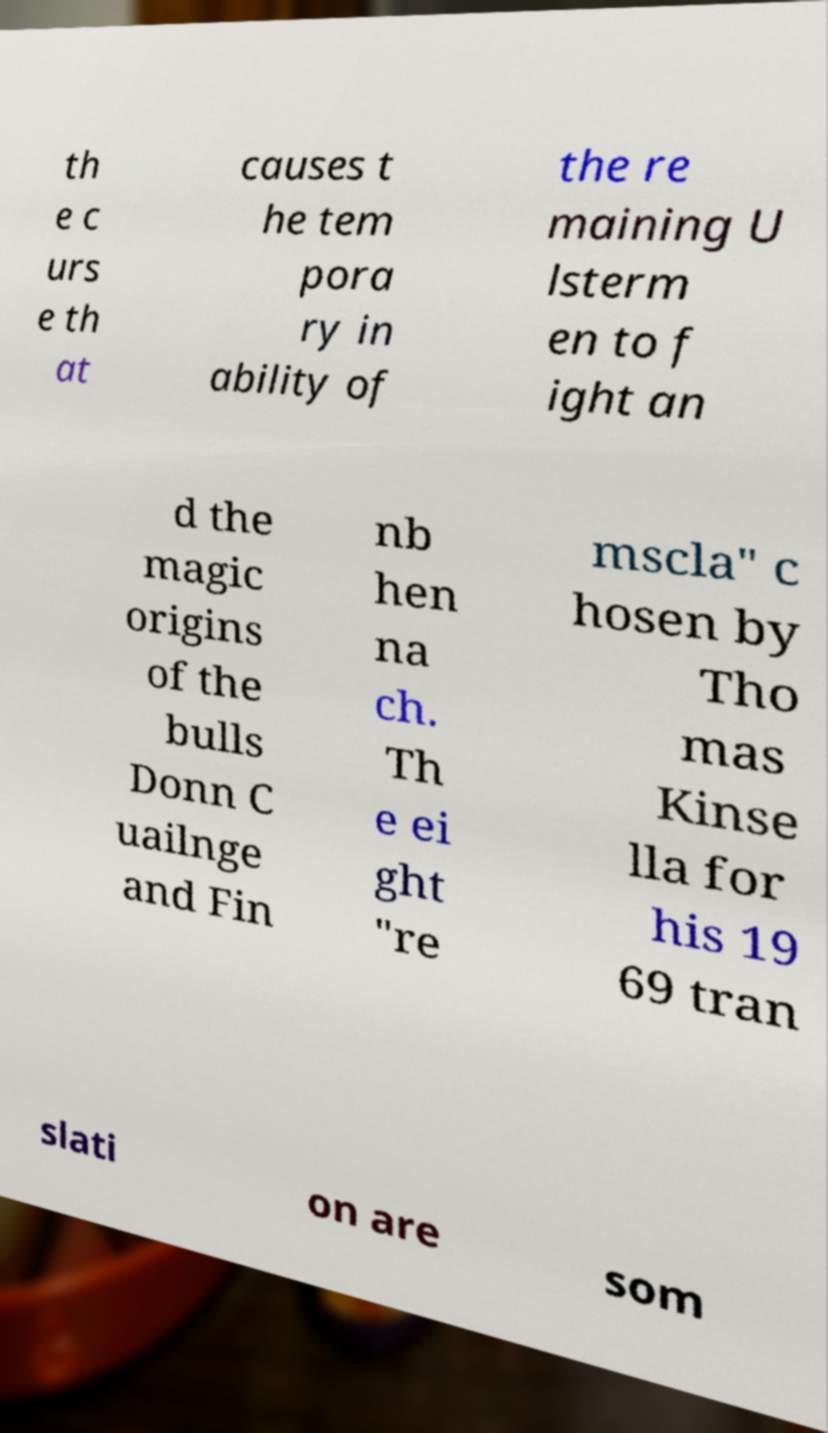I need the written content from this picture converted into text. Can you do that? th e c urs e th at causes t he tem pora ry in ability of the re maining U lsterm en to f ight an d the magic origins of the bulls Donn C uailnge and Fin nb hen na ch. Th e ei ght "re mscla" c hosen by Tho mas Kinse lla for his 19 69 tran slati on are som 